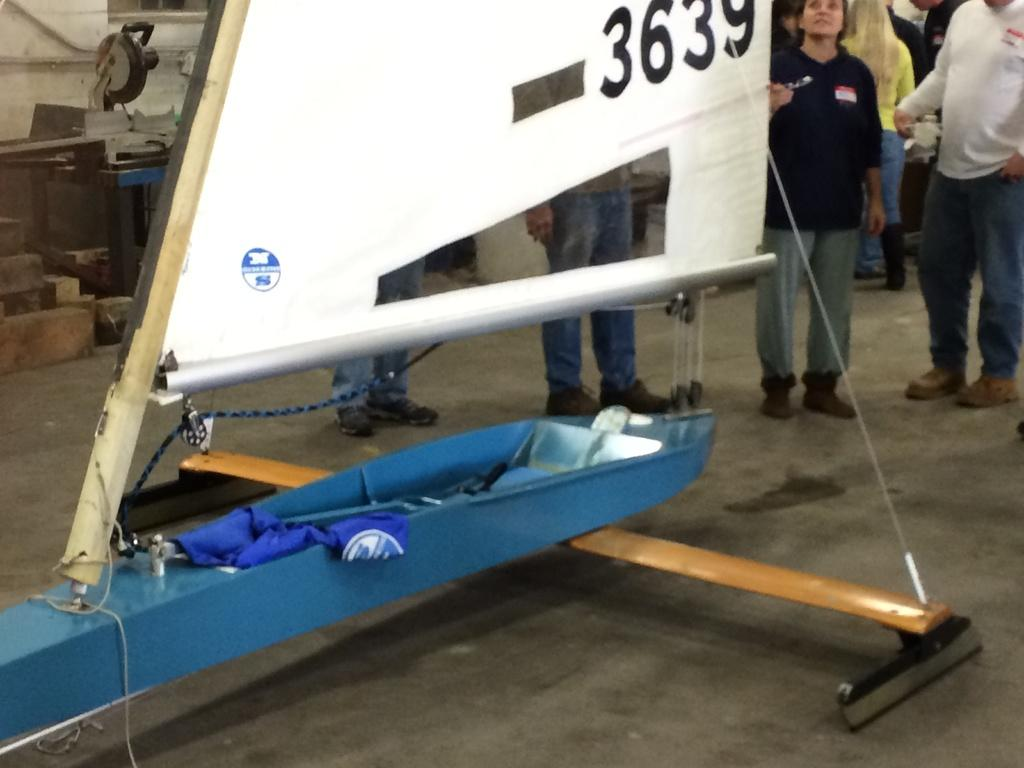Provide a one-sentence caption for the provided image. A model of a 3639 boat is displayed in an exhibit. 